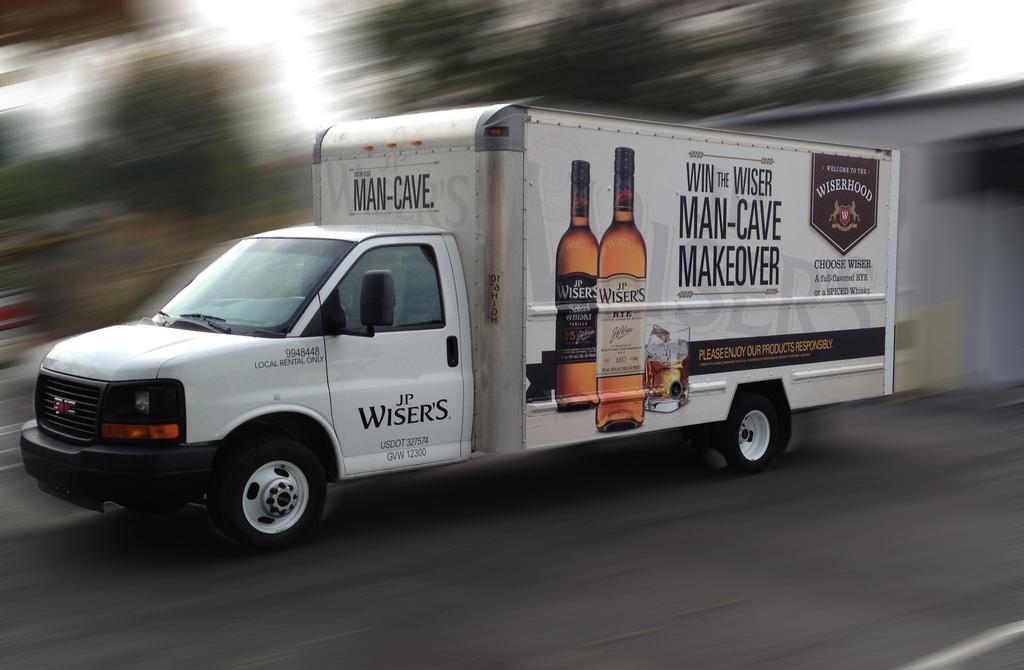Which drink company is featured?
Make the answer very short. Jp wisers. What is after man-cave?
Give a very brief answer. Makeover. 